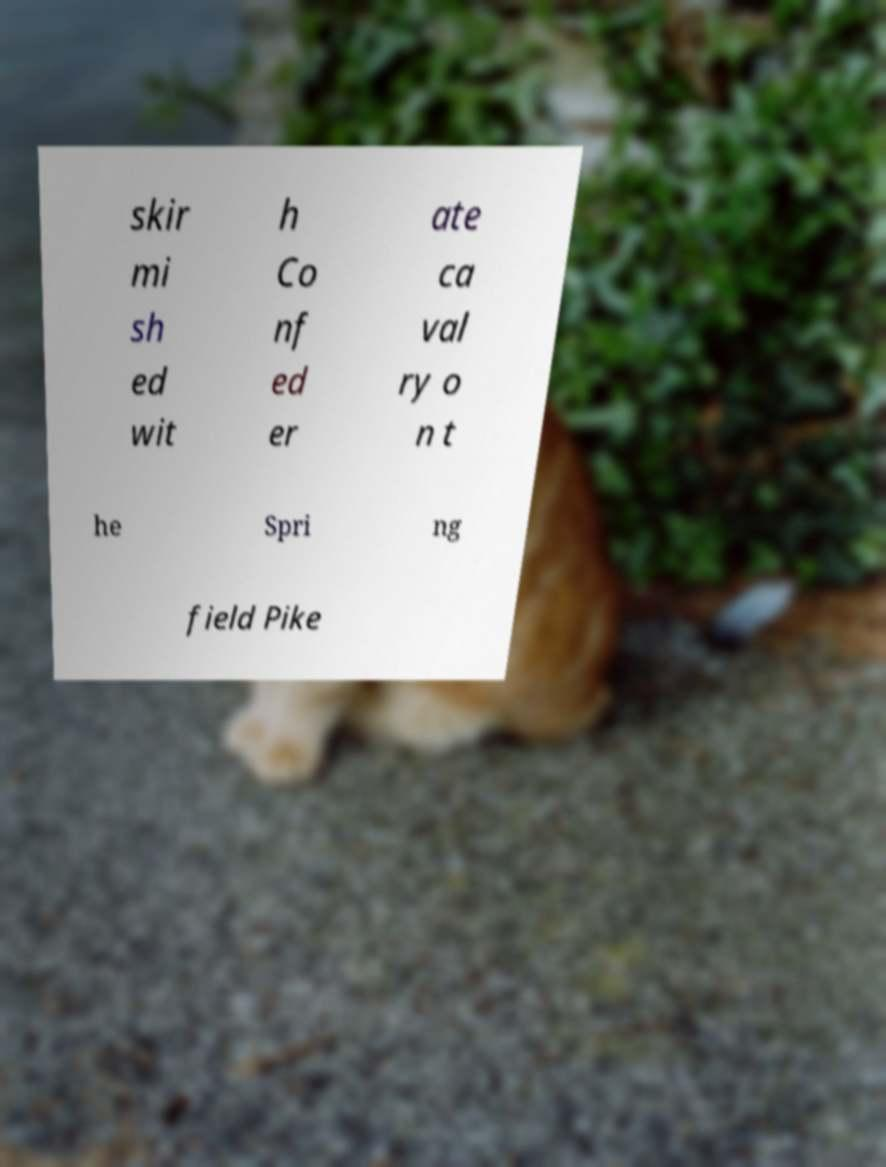For documentation purposes, I need the text within this image transcribed. Could you provide that? skir mi sh ed wit h Co nf ed er ate ca val ry o n t he Spri ng field Pike 